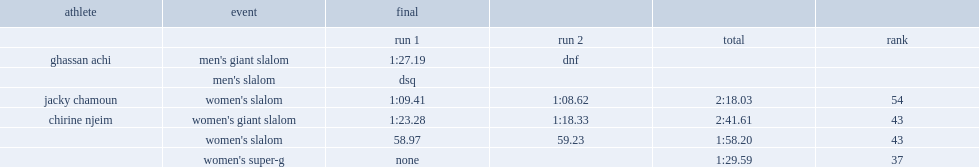What was the combined time did chamoun get in the final? 2:18.03. 